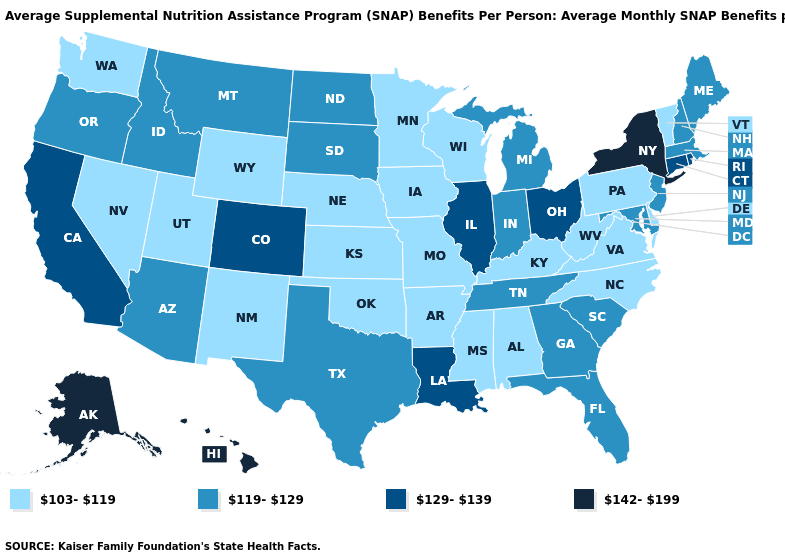What is the value of New York?
Concise answer only. 142-199. Name the states that have a value in the range 103-119?
Answer briefly. Alabama, Arkansas, Delaware, Iowa, Kansas, Kentucky, Minnesota, Mississippi, Missouri, Nebraska, Nevada, New Mexico, North Carolina, Oklahoma, Pennsylvania, Utah, Vermont, Virginia, Washington, West Virginia, Wisconsin, Wyoming. Among the states that border Colorado , does Arizona have the highest value?
Be succinct. Yes. Name the states that have a value in the range 119-129?
Write a very short answer. Arizona, Florida, Georgia, Idaho, Indiana, Maine, Maryland, Massachusetts, Michigan, Montana, New Hampshire, New Jersey, North Dakota, Oregon, South Carolina, South Dakota, Tennessee, Texas. Does Nebraska have the lowest value in the USA?
Short answer required. Yes. What is the value of Texas?
Answer briefly. 119-129. Among the states that border New York , does Vermont have the lowest value?
Concise answer only. Yes. What is the value of California?
Concise answer only. 129-139. What is the lowest value in states that border Utah?
Short answer required. 103-119. Name the states that have a value in the range 142-199?
Concise answer only. Alaska, Hawaii, New York. What is the value of New Mexico?
Be succinct. 103-119. What is the value of Pennsylvania?
Write a very short answer. 103-119. Does Oklahoma have the same value as Hawaii?
Answer briefly. No. What is the lowest value in the Northeast?
Keep it brief. 103-119. Name the states that have a value in the range 142-199?
Quick response, please. Alaska, Hawaii, New York. 